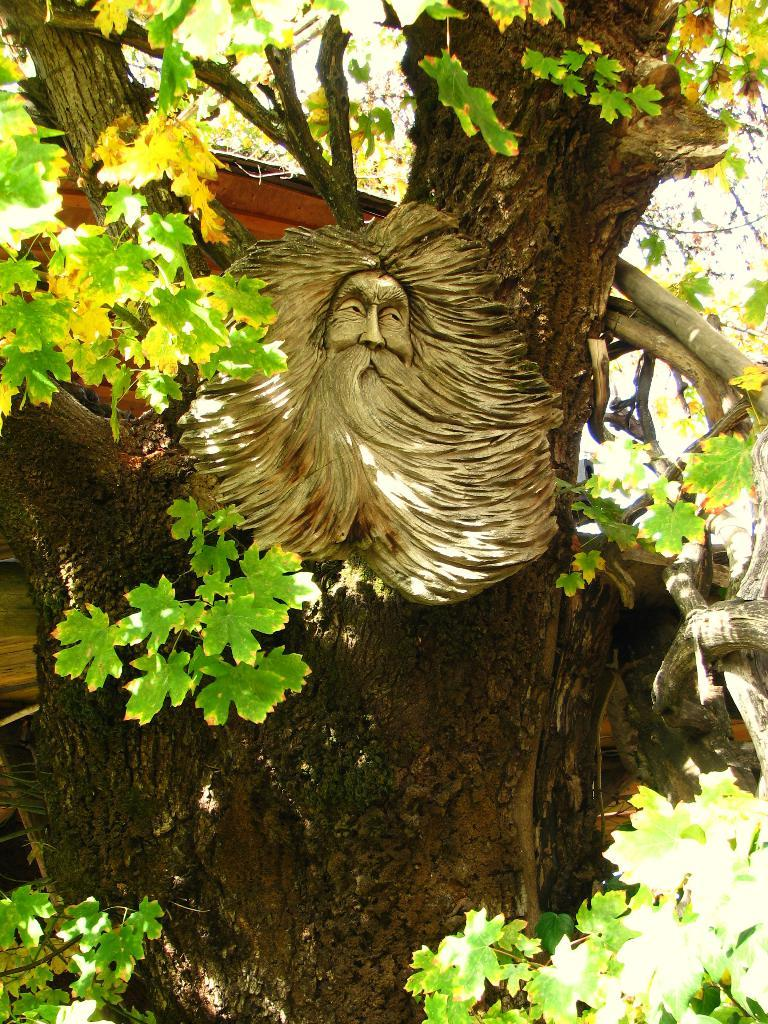What is the main subject of the image? The main subject of the image is a sculpture of a person's face. What material appears to have been used to create the sculpture? The sculpture appears to be made from a tree trunk. Can you describe any other natural elements in the image? Yes, there is a tree with branches and leaves in the image. What day of the week is depicted in the image? The image does not depict a day of the week; it features a sculpture and a tree. What scientific theory can be observed in the image? There is no scientific theory present in the image; it shows a sculpture and a tree. 